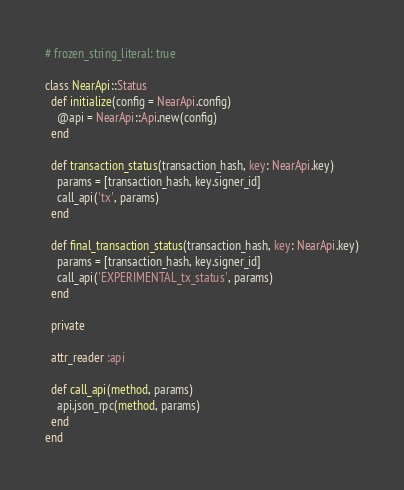Convert code to text. <code><loc_0><loc_0><loc_500><loc_500><_Ruby_># frozen_string_literal: true

class NearApi::Status
  def initialize(config = NearApi.config)
    @api = NearApi::Api.new(config)
  end

  def transaction_status(transaction_hash, key: NearApi.key)
    params = [transaction_hash, key.signer_id]
    call_api('tx', params)
  end

  def final_transaction_status(transaction_hash, key: NearApi.key)
    params = [transaction_hash, key.signer_id]
    call_api('EXPERIMENTAL_tx_status', params)
  end

  private

  attr_reader :api

  def call_api(method, params)
    api.json_rpc(method, params)
  end
end
</code> 